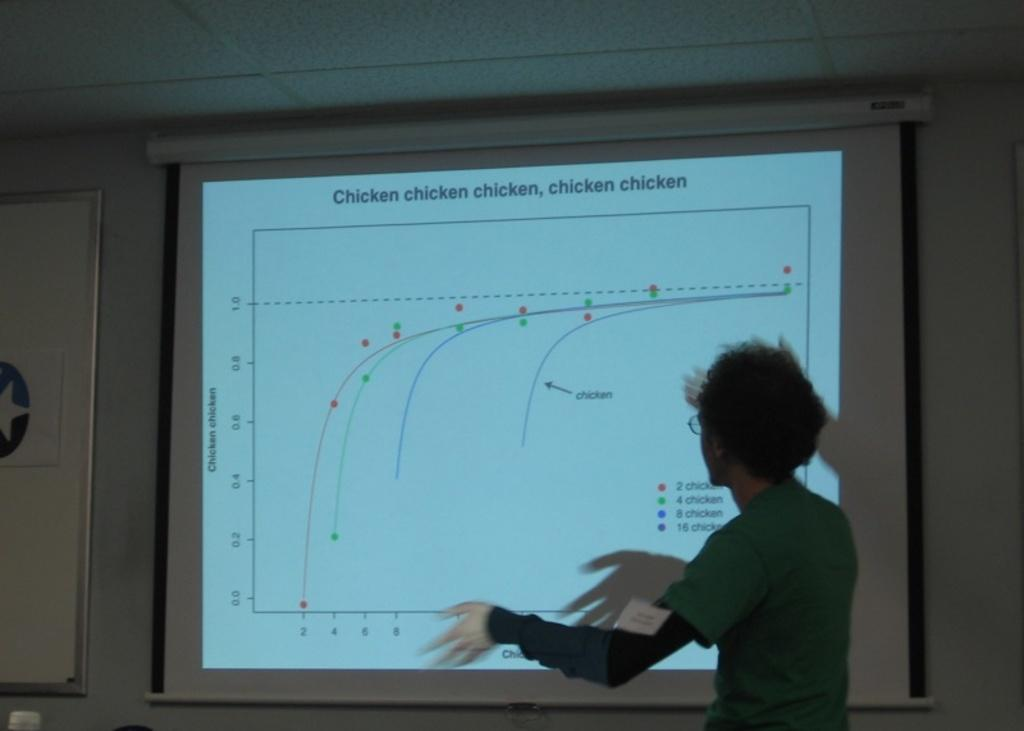<image>
Write a terse but informative summary of the picture. A person is explaining a chart projected on the wall about chicken. 